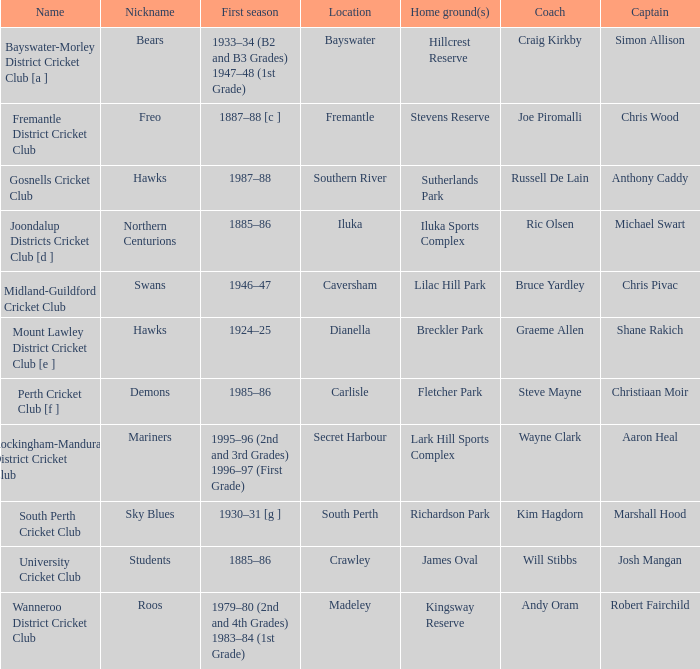On which dates is hillcrest reserve considered the home grounds? 1933–34 (B2 and B3 Grades) 1947–48 (1st Grade). 